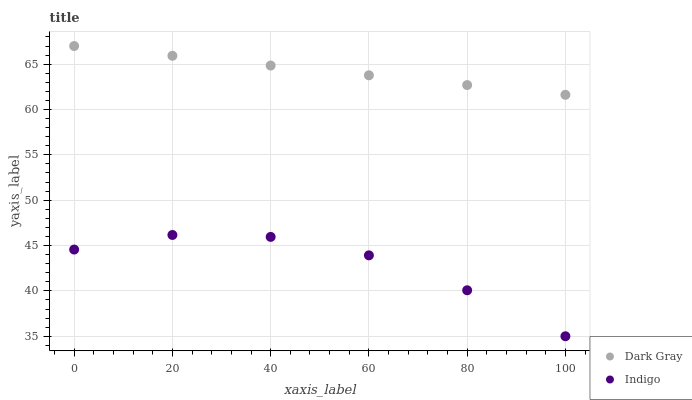Does Indigo have the minimum area under the curve?
Answer yes or no. Yes. Does Dark Gray have the maximum area under the curve?
Answer yes or no. Yes. Does Indigo have the maximum area under the curve?
Answer yes or no. No. Is Dark Gray the smoothest?
Answer yes or no. Yes. Is Indigo the roughest?
Answer yes or no. Yes. Is Indigo the smoothest?
Answer yes or no. No. Does Indigo have the lowest value?
Answer yes or no. Yes. Does Dark Gray have the highest value?
Answer yes or no. Yes. Does Indigo have the highest value?
Answer yes or no. No. Is Indigo less than Dark Gray?
Answer yes or no. Yes. Is Dark Gray greater than Indigo?
Answer yes or no. Yes. Does Indigo intersect Dark Gray?
Answer yes or no. No. 